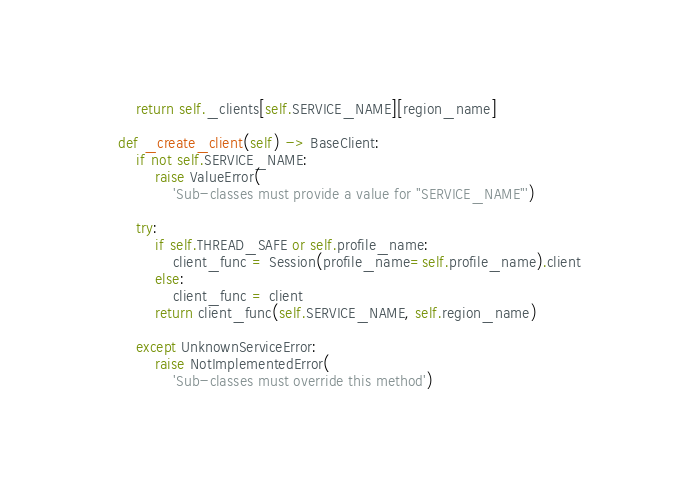<code> <loc_0><loc_0><loc_500><loc_500><_Python_>        return self._clients[self.SERVICE_NAME][region_name]

    def _create_client(self) -> BaseClient:
        if not self.SERVICE_NAME:
            raise ValueError(
                'Sub-classes must provide a value for "SERVICE_NAME"')

        try:
            if self.THREAD_SAFE or self.profile_name:
                client_func = Session(profile_name=self.profile_name).client
            else:
                client_func = client
            return client_func(self.SERVICE_NAME, self.region_name)

        except UnknownServiceError:
            raise NotImplementedError(
                'Sub-classes must override this method')
</code> 